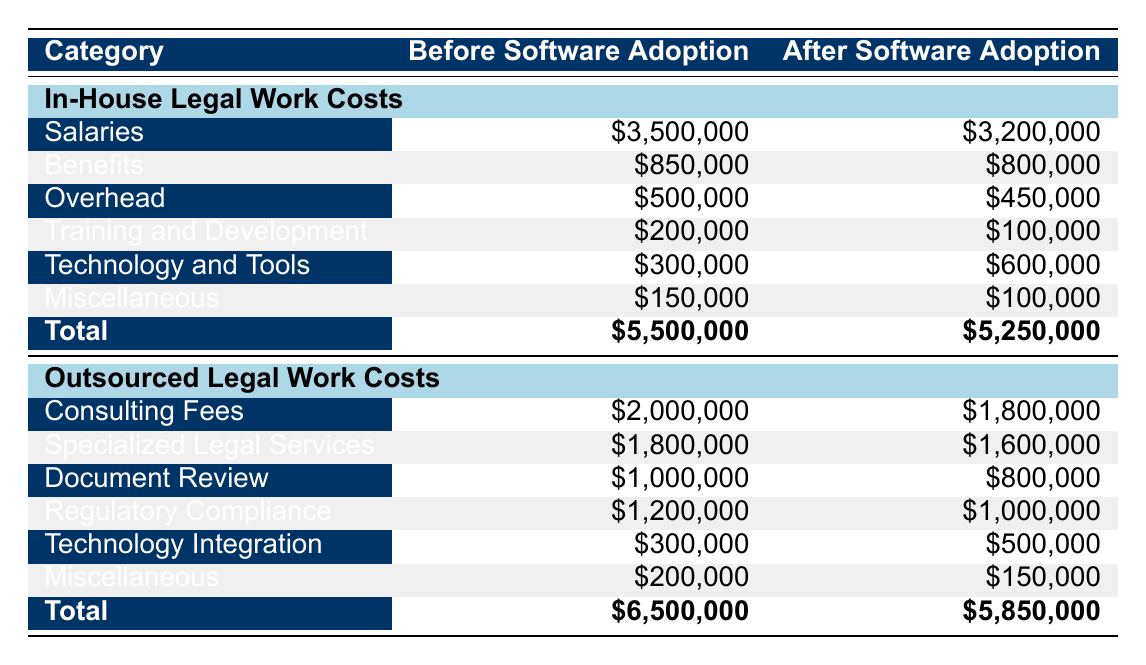What are the total In-House Legal Work Costs before software adoption? The table shows the total for In-House Legal Work Costs before software adoption listed as '$5,500,000'.
Answer: 5,500,000 What was the decrease in salaries for In-House Legal Work Costs after software adoption? Salaries before adoption were '$3,500,000' and after adoption were '$3,200,000'. The decrease is calculated as '$3,500,000 - $3,200,000 = $300,000'.
Answer: 300,000 Is the total cost of Outsourced Legal Work higher before or after software adoption? The total cost of Outsourced Legal Work before software adoption is '$6,500,000', while after is '$5,850,000'. Since '$6,500,000' is greater than '$5,850,000', the cost is higher before adoption.
Answer: Yes How much did Document Review costs change from before to after software adoption? The Document Review cost before adoption was '$1,000,000'. After adoption, it dropped to '$800,000'. The change is calculated as '$1,000,000 - $800,000 = $200,000'.
Answer: 200,000 What is the total decrease in costs for In-House Legal Work from before to after software adoption? The total costs before software adoption were '$5,500,000' and after were '$5,250,000'. The total decrease is calculated as '$5,500,000 - $5,250,000 = $250,000'.
Answer: 250,000 Is it true that the Technology Integration cost increased after software adoption? The Technology Integration cost before adoption was '$300,000', and after it increased to '$500,000'. Since the cost increased, the statement is true.
Answer: Yes What is the difference in the total costs between In-House and Outsourced Legal Work after software adoption? The total for In-House Legal Work after adoption is '$5,250,000' and for Outsourced is '$5,850,000'. The difference is '$5,850,000 - $5,250,000 = $600,000'.
Answer: 600,000 How much was spent on Training and Development for In-House Legal Work after software adoption? After software adoption, Training and Development costs are listed as '$100,000' in the table under In-House Legal Work Costs.
Answer: 100,000 What is the total cost for Specialized Legal Services before software adoption? The table indicates that the cost for Specialized Legal Services before adoption is '$1,800,000'.
Answer: 1,800,000 